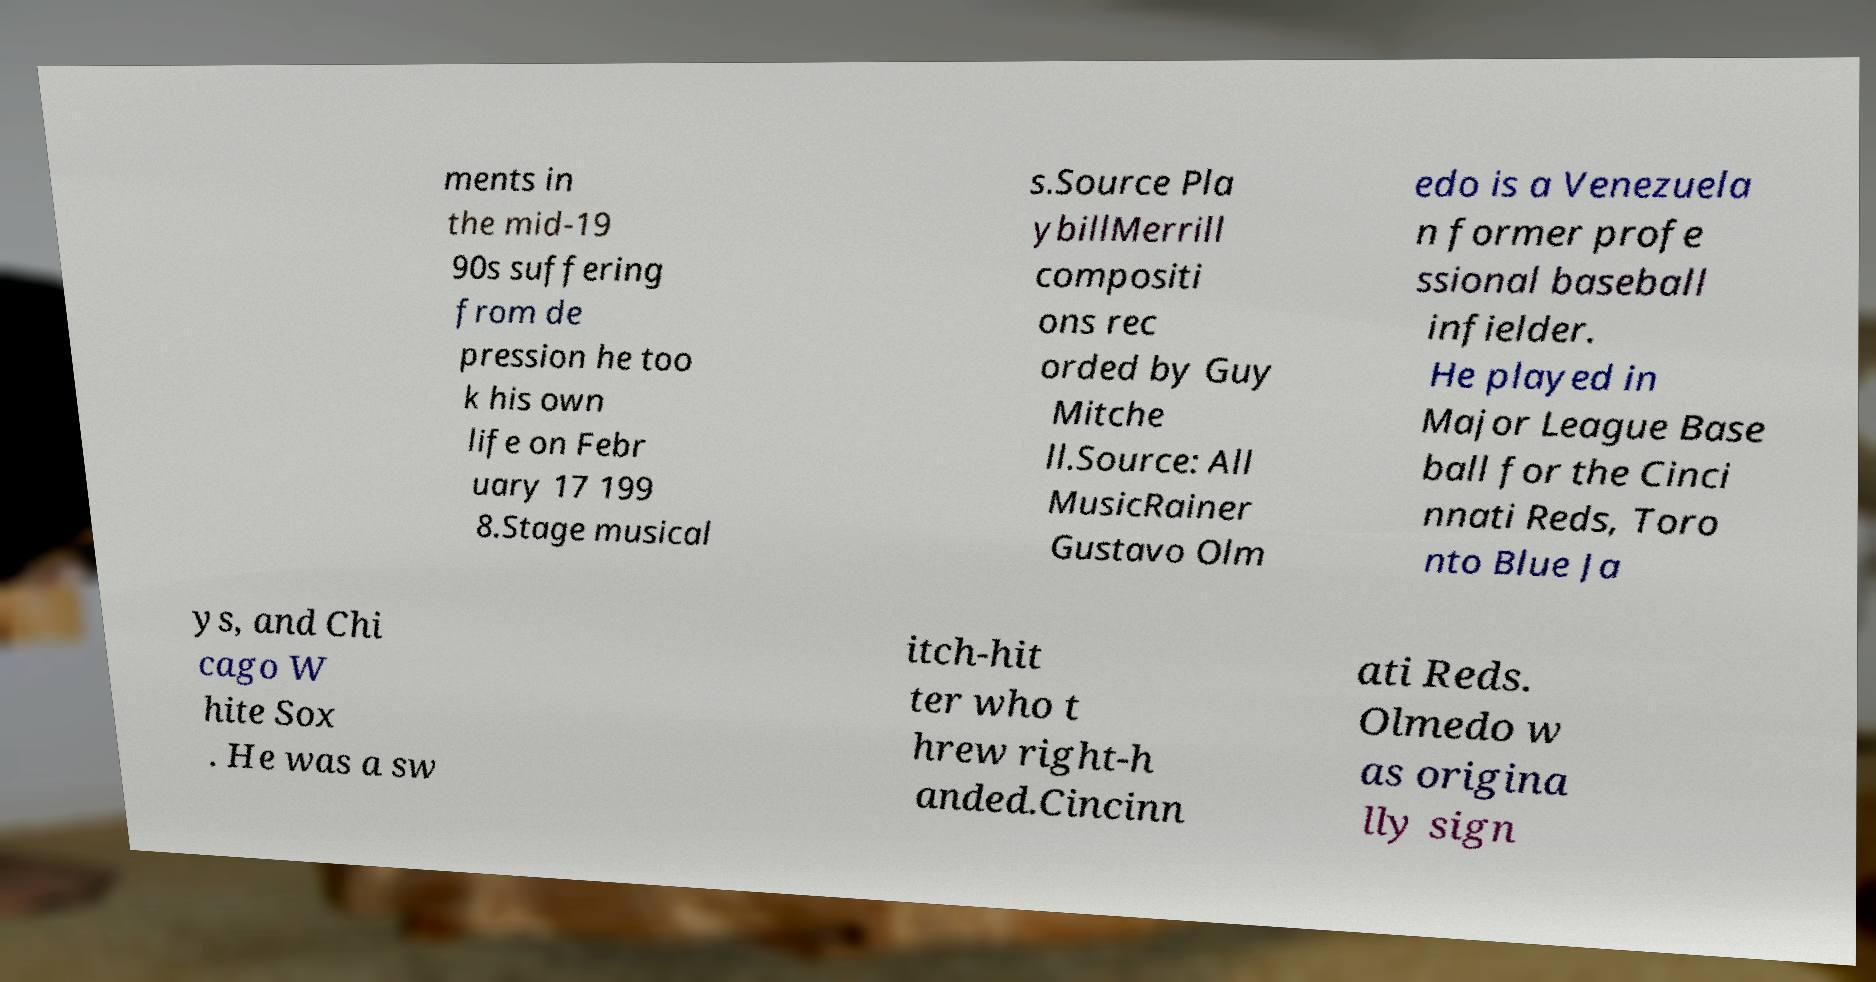What messages or text are displayed in this image? I need them in a readable, typed format. ments in the mid-19 90s suffering from de pression he too k his own life on Febr uary 17 199 8.Stage musical s.Source Pla ybillMerrill compositi ons rec orded by Guy Mitche ll.Source: All MusicRainer Gustavo Olm edo is a Venezuela n former profe ssional baseball infielder. He played in Major League Base ball for the Cinci nnati Reds, Toro nto Blue Ja ys, and Chi cago W hite Sox . He was a sw itch-hit ter who t hrew right-h anded.Cincinn ati Reds. Olmedo w as origina lly sign 